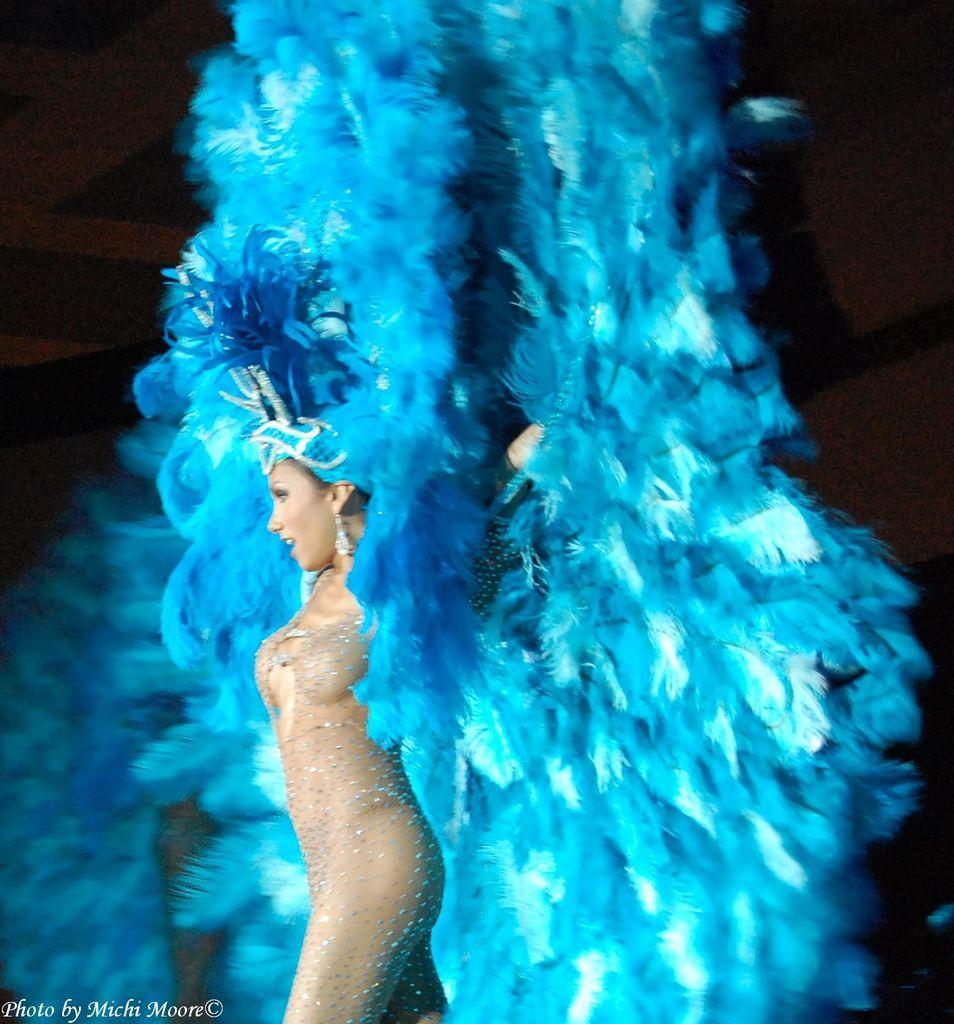Describe this image in one or two sentences. Here in this picture we can see a woman walking on the stage, as we can see she is wearing a decorated costume on her and she is smiling. 